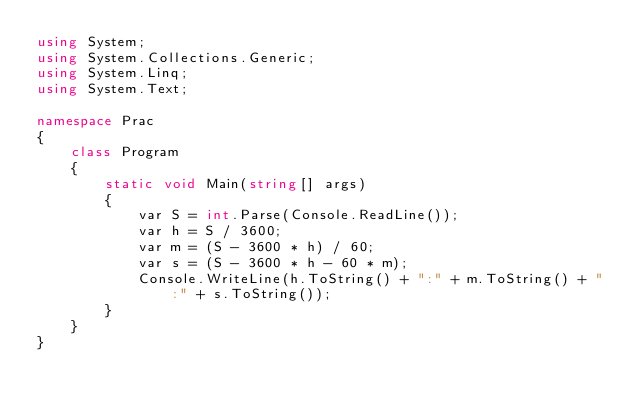Convert code to text. <code><loc_0><loc_0><loc_500><loc_500><_C#_>using System;
using System.Collections.Generic;
using System.Linq;
using System.Text;

namespace Prac
{
    class Program
    {
        static void Main(string[] args)
        {
            var S = int.Parse(Console.ReadLine());
            var h = S / 3600;
            var m = (S - 3600 * h) / 60;
            var s = (S - 3600 * h - 60 * m);
            Console.WriteLine(h.ToString() + ":" + m.ToString() + ":" + s.ToString());
        }
    }
}</code> 